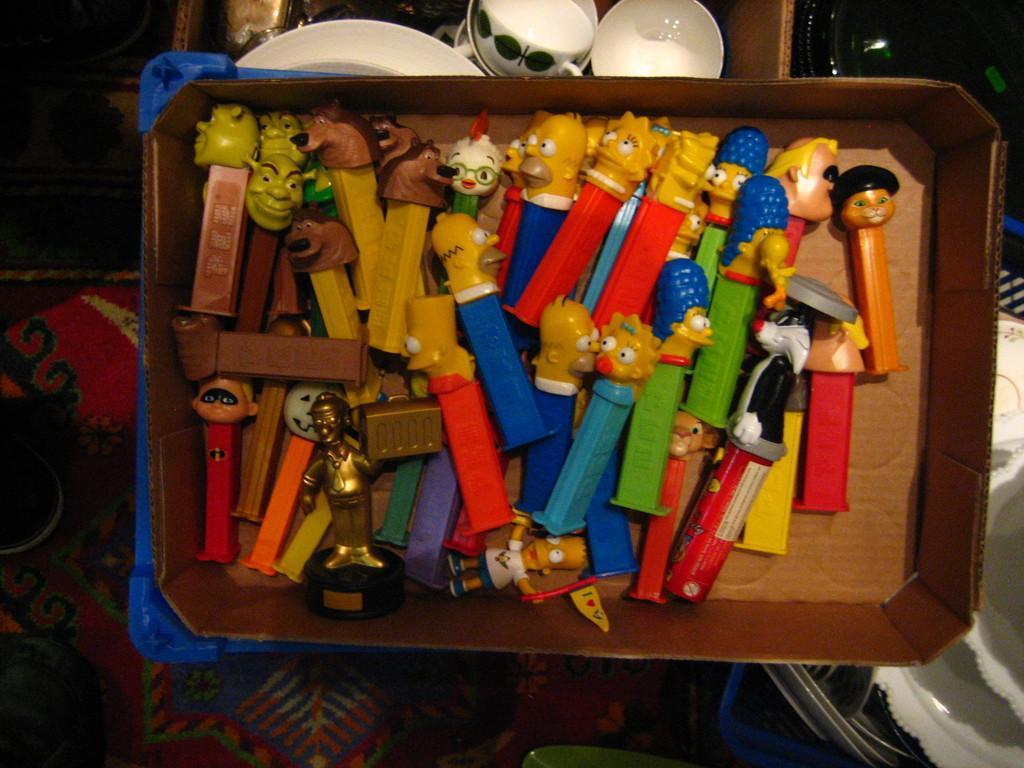Describe this image in one or two sentences. In the picture we can see a wooden tray in it, we can see some toys and beside the tree we can see some cups and saucers which are white in color and we can also see some plates and bowls. 